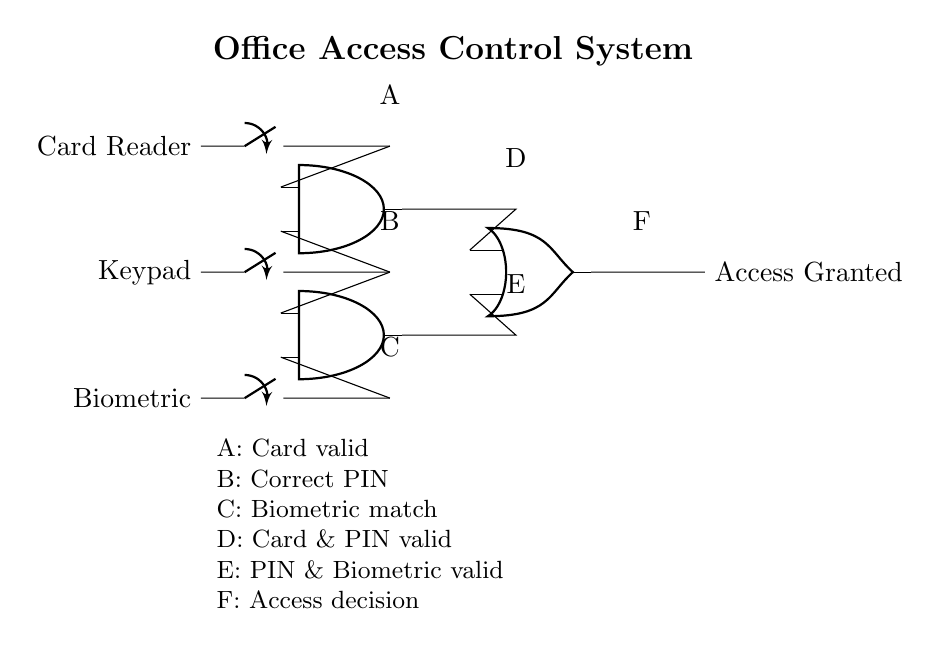What are the inputs of the system? The inputs of the system are the Card Reader, Keypad, and Biometric. These are marked as A, B, and C in the circuit diagram, representing the various methods of access input.
Answer: Card Reader, Keypad, Biometric How many AND gates are used in this circuit? The circuit contains two AND gates, indicated by the nodes labeled at positions for input and output of the gates, respectively.
Answer: 2 What is the output of the OR gate? The output of the OR gate is labeled as "Access Granted," which signifies the final output of the security system based on the inputs processed through the gates.
Answer: Access Granted What combination of inputs does the first AND gate require for its output? The first AND gate requires both the Card Reader and Keypad inputs to be active (true). This is deduced from the connections leading to the first AND gate labeled D in the diagram.
Answer: Card & PIN valid If only the Biometric input is active, what will be the output of the system? If only the Biometric input is active, the two AND gates will not receive enough active inputs to produce a true output, and consequently, the final output will be "Access Denied." The reasoning is based on the functionality of both AND gates needing multiple active inputs to result in true logic.
Answer: Access Denied What does the node labeled E represent in the circuit? The node labeled E represents the output of the second AND gate, which indicates that the PIN and Biometric inputs must be valid for this stage to output a true value.
Answer: PIN & Biometric valid Which logic gate determines the final output for granting access? The final output for granting access is determined by the OR gate. This gate evaluates its inputs from the AND gates, providing a single output based on their states—either granting or denying access based on active inputs.
Answer: OR gate 